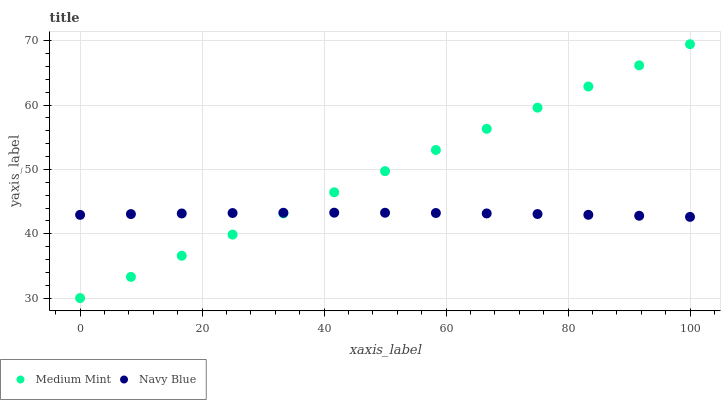Does Navy Blue have the minimum area under the curve?
Answer yes or no. Yes. Does Medium Mint have the maximum area under the curve?
Answer yes or no. Yes. Does Navy Blue have the maximum area under the curve?
Answer yes or no. No. Is Medium Mint the smoothest?
Answer yes or no. Yes. Is Navy Blue the roughest?
Answer yes or no. Yes. Is Navy Blue the smoothest?
Answer yes or no. No. Does Medium Mint have the lowest value?
Answer yes or no. Yes. Does Navy Blue have the lowest value?
Answer yes or no. No. Does Medium Mint have the highest value?
Answer yes or no. Yes. Does Navy Blue have the highest value?
Answer yes or no. No. Does Navy Blue intersect Medium Mint?
Answer yes or no. Yes. Is Navy Blue less than Medium Mint?
Answer yes or no. No. Is Navy Blue greater than Medium Mint?
Answer yes or no. No. 